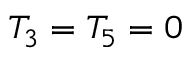<formula> <loc_0><loc_0><loc_500><loc_500>T _ { 3 } = T _ { 5 } = 0</formula> 